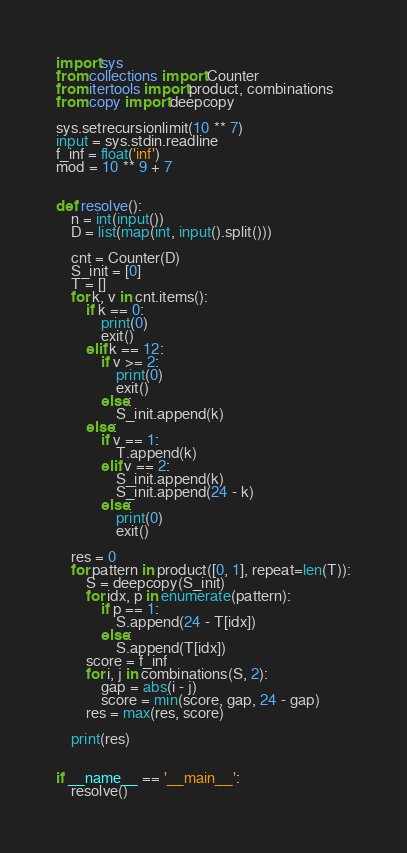<code> <loc_0><loc_0><loc_500><loc_500><_Python_>import sys
from collections import Counter
from itertools import product, combinations
from copy import deepcopy

sys.setrecursionlimit(10 ** 7)
input = sys.stdin.readline
f_inf = float('inf')
mod = 10 ** 9 + 7


def resolve():
    n = int(input())
    D = list(map(int, input().split()))

    cnt = Counter(D)
    S_init = [0]
    T = []
    for k, v in cnt.items():
        if k == 0:
            print(0)
            exit()
        elif k == 12:
            if v >= 2:
                print(0)
                exit()
            else:
                S_init.append(k)
        else:
            if v == 1:
                T.append(k)
            elif v == 2:
                S_init.append(k)
                S_init.append(24 - k)
            else:
                print(0)
                exit()

    res = 0
    for pattern in product([0, 1], repeat=len(T)):
        S = deepcopy(S_init)
        for idx, p in enumerate(pattern):
            if p == 1:
                S.append(24 - T[idx])
            else:
                S.append(T[idx])
        score = f_inf
        for i, j in combinations(S, 2):
            gap = abs(i - j)
            score = min(score, gap, 24 - gap)
        res = max(res, score)

    print(res)


if __name__ == '__main__':
    resolve()
</code> 